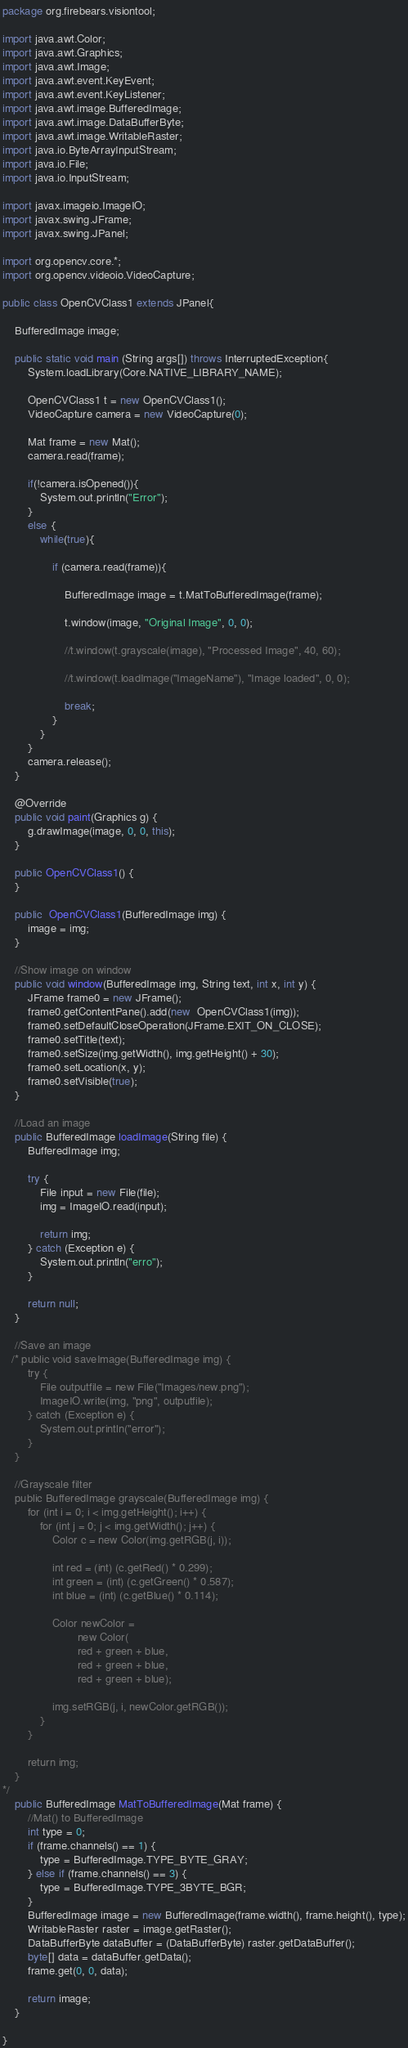Convert code to text. <code><loc_0><loc_0><loc_500><loc_500><_Java_>package org.firebears.visiontool;

import java.awt.Color;
import java.awt.Graphics;
import java.awt.Image;
import java.awt.event.KeyEvent;
import java.awt.event.KeyListener;
import java.awt.image.BufferedImage;
import java.awt.image.DataBufferByte;
import java.awt.image.WritableRaster;
import java.io.ByteArrayInputStream;
import java.io.File;
import java.io.InputStream;

import javax.imageio.ImageIO;
import javax.swing.JFrame;
import javax.swing.JPanel;

import org.opencv.core.*;
import org.opencv.videoio.VideoCapture;        

public class OpenCVClass1 extends JPanel{

    BufferedImage image;

    public static void main (String args[]) throws InterruptedException{
        System.loadLibrary(Core.NATIVE_LIBRARY_NAME);

        OpenCVClass1 t = new OpenCVClass1();
        VideoCapture camera = new VideoCapture(0);

        Mat frame = new Mat();
        camera.read(frame); 

        if(!camera.isOpened()){
            System.out.println("Error");
        }
        else {                  
            while(true){        

                if (camera.read(frame)){

                    BufferedImage image = t.MatToBufferedImage(frame);

                    t.window(image, "Original Image", 0, 0);

                    //t.window(t.grayscale(image), "Processed Image", 40, 60);

                    //t.window(t.loadImage("ImageName"), "Image loaded", 0, 0);

                    break;
                }
            }   
        }
        camera.release();
    }

    @Override
    public void paint(Graphics g) {
        g.drawImage(image, 0, 0, this);
    }

    public OpenCVClass1() {
    }

    public  OpenCVClass1(BufferedImage img) {
        image = img;
    }   

    //Show image on window
    public void window(BufferedImage img, String text, int x, int y) {
        JFrame frame0 = new JFrame();
        frame0.getContentPane().add(new  OpenCVClass1(img));
        frame0.setDefaultCloseOperation(JFrame.EXIT_ON_CLOSE);
        frame0.setTitle(text);
        frame0.setSize(img.getWidth(), img.getHeight() + 30);
        frame0.setLocation(x, y);
        frame0.setVisible(true);
    }

    //Load an image
    public BufferedImage loadImage(String file) {
        BufferedImage img;

        try {
            File input = new File(file);
            img = ImageIO.read(input);

            return img;
        } catch (Exception e) {
            System.out.println("erro");
        }

        return null;
    }

    //Save an image
   /* public void saveImage(BufferedImage img) {        
        try {
            File outputfile = new File("Images/new.png");
            ImageIO.write(img, "png", outputfile);
        } catch (Exception e) {
            System.out.println("error");
        }
    }

    //Grayscale filter
    public BufferedImage grayscale(BufferedImage img) {
        for (int i = 0; i < img.getHeight(); i++) {
            for (int j = 0; j < img.getWidth(); j++) {
                Color c = new Color(img.getRGB(j, i));

                int red = (int) (c.getRed() * 0.299);
                int green = (int) (c.getGreen() * 0.587);
                int blue = (int) (c.getBlue() * 0.114);

                Color newColor =
                        new Color(
                        red + green + blue,
                        red + green + blue,
                        red + green + blue);

                img.setRGB(j, i, newColor.getRGB());
            }
        }

        return img;
    }
*/
    public BufferedImage MatToBufferedImage(Mat frame) {
        //Mat() to BufferedImage
        int type = 0;
        if (frame.channels() == 1) {
            type = BufferedImage.TYPE_BYTE_GRAY;
        } else if (frame.channels() == 3) {
            type = BufferedImage.TYPE_3BYTE_BGR;
        }
        BufferedImage image = new BufferedImage(frame.width(), frame.height(), type);
        WritableRaster raster = image.getRaster();
        DataBufferByte dataBuffer = (DataBufferByte) raster.getDataBuffer();
        byte[] data = dataBuffer.getData();
        frame.get(0, 0, data);

        return image;
    }

}</code> 